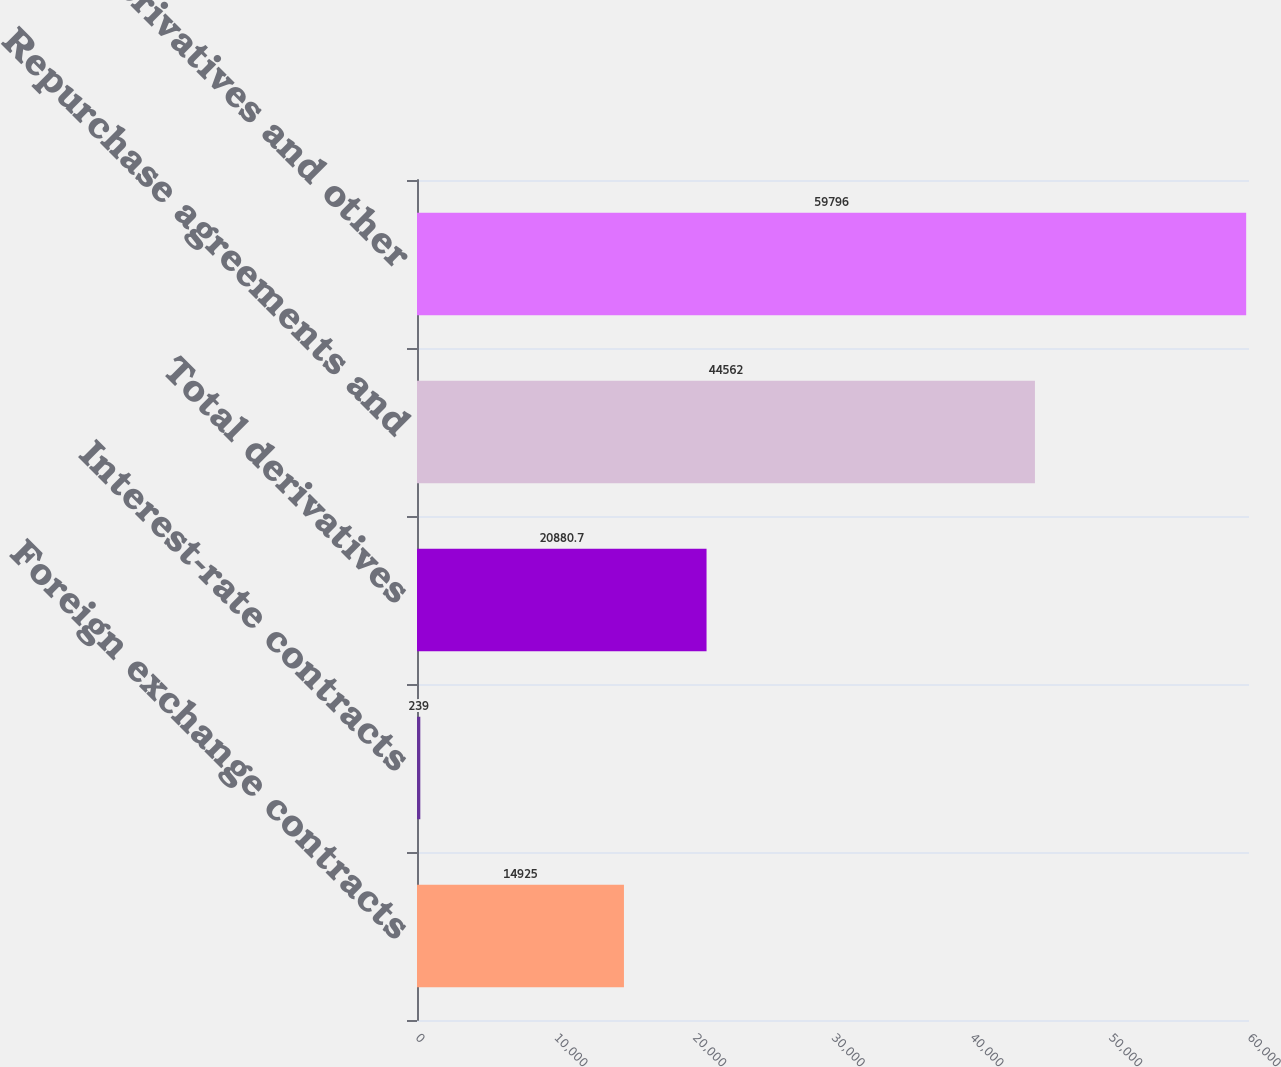Convert chart to OTSL. <chart><loc_0><loc_0><loc_500><loc_500><bar_chart><fcel>Foreign exchange contracts<fcel>Interest-rate contracts<fcel>Total derivatives<fcel>Repurchase agreements and<fcel>Total derivatives and other<nl><fcel>14925<fcel>239<fcel>20880.7<fcel>44562<fcel>59796<nl></chart> 